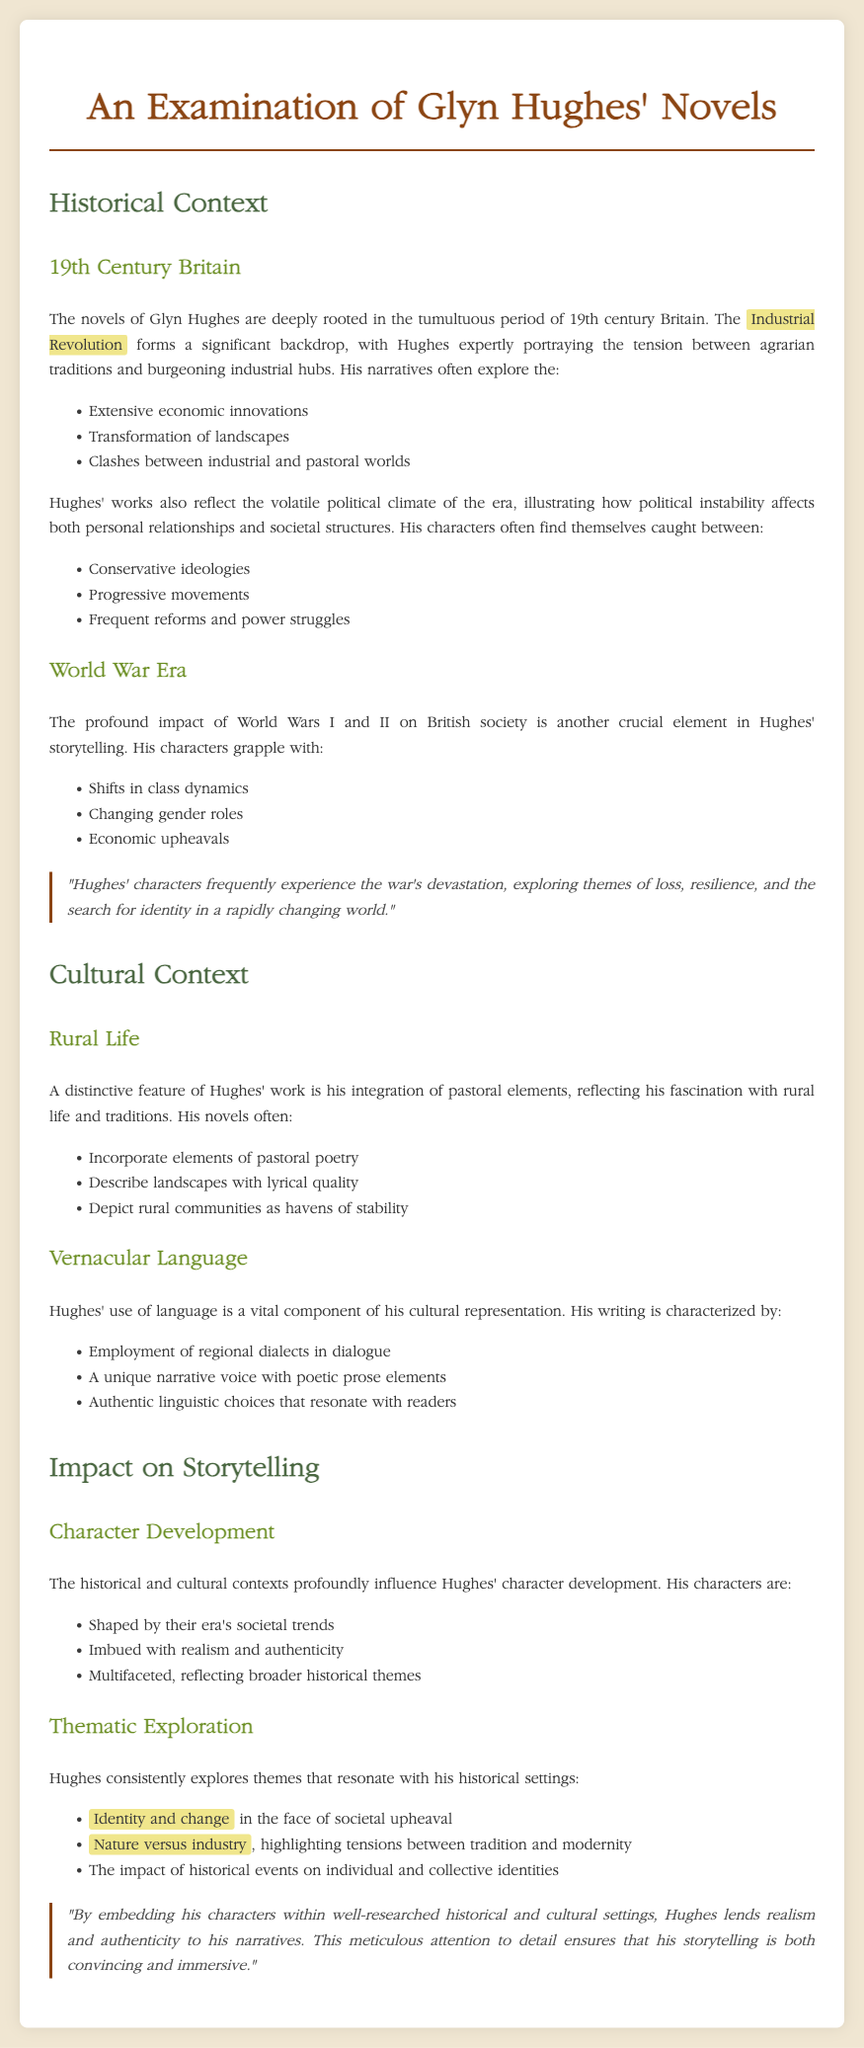What significant backdrop does Hughes explore in his novels? The document states that the significant backdrop explored in Hughes' novels is the Industrial Revolution.
Answer: Industrial Revolution What are the three aspects Hughes often portrays in the context of the Industrial Revolution? The document lists extensive economic innovations, transformation of landscapes, and clashes between industrial and pastoral worlds.
Answer: Economic innovations, transformation of landscapes, clashes between industrial and pastoral worlds Which two elements are frequently experienced by Hughes' characters due to World War I and II? The document mentions shifts in class dynamics and changing gender roles as elements frequently experienced by characters.
Answer: Shifts in class dynamics, changing gender roles What literary feature does Hughes integrate into his work that reflects his fascination with rural life? The document states that Hughes incorporates elements of pastoral poetry into his work.
Answer: Elements of pastoral poetry How does Hughes' use of language contribute to his cultural representation? The document indicates that Hughes' writing is characterized by the employment of regional dialects in dialogue.
Answer: Employment of regional dialects in dialogue What theme related to change does Hughes explore in his storytelling? According to the document, Hughes explores the theme of identity and change in the face of societal upheaval.
Answer: Identity and change How does Hughes achieve realism in character development? The document explains that his characters are shaped by their era's societal trends, adding realism and authenticity.
Answer: Shaped by their era's societal trends What impact do historical events have on Hughes' characters, as mentioned in the document? The document notes that historical events impact individual and collective identities.
Answer: Individual and collective identities 